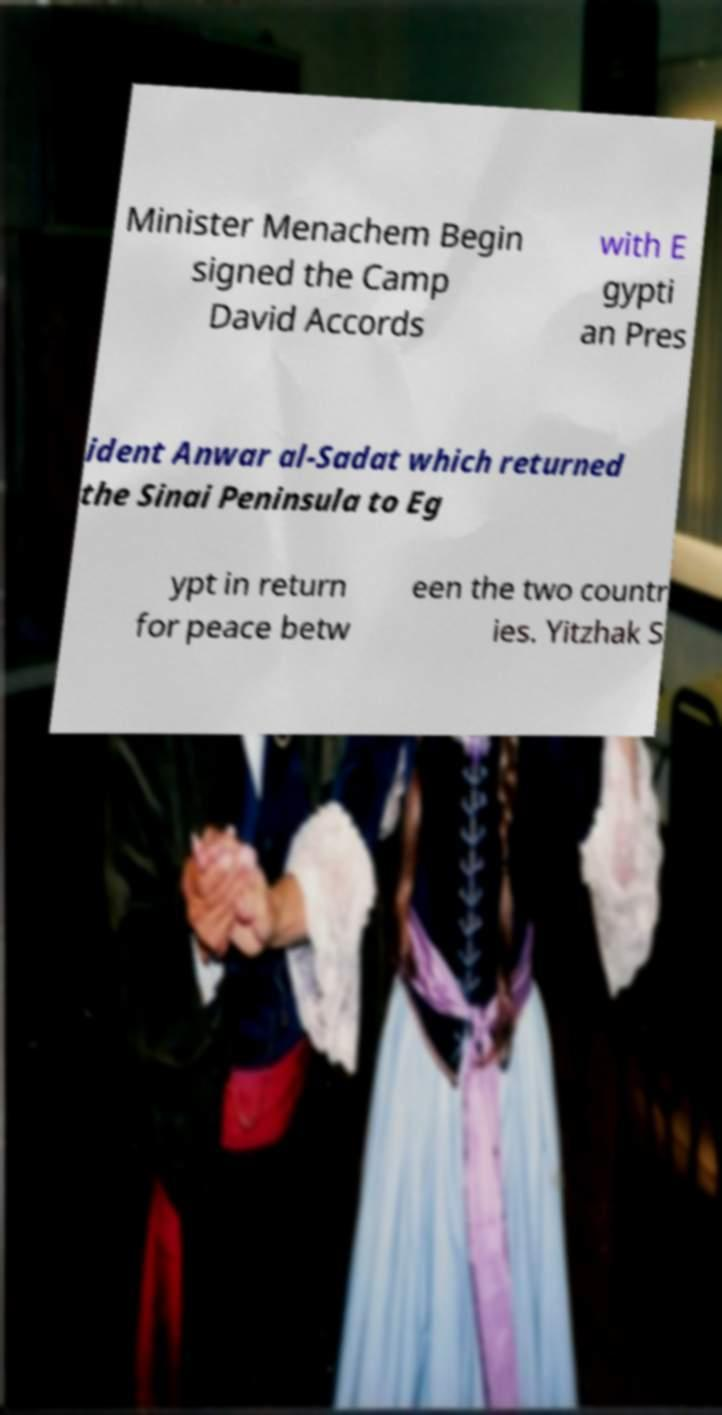Please identify and transcribe the text found in this image. Minister Menachem Begin signed the Camp David Accords with E gypti an Pres ident Anwar al-Sadat which returned the Sinai Peninsula to Eg ypt in return for peace betw een the two countr ies. Yitzhak S 